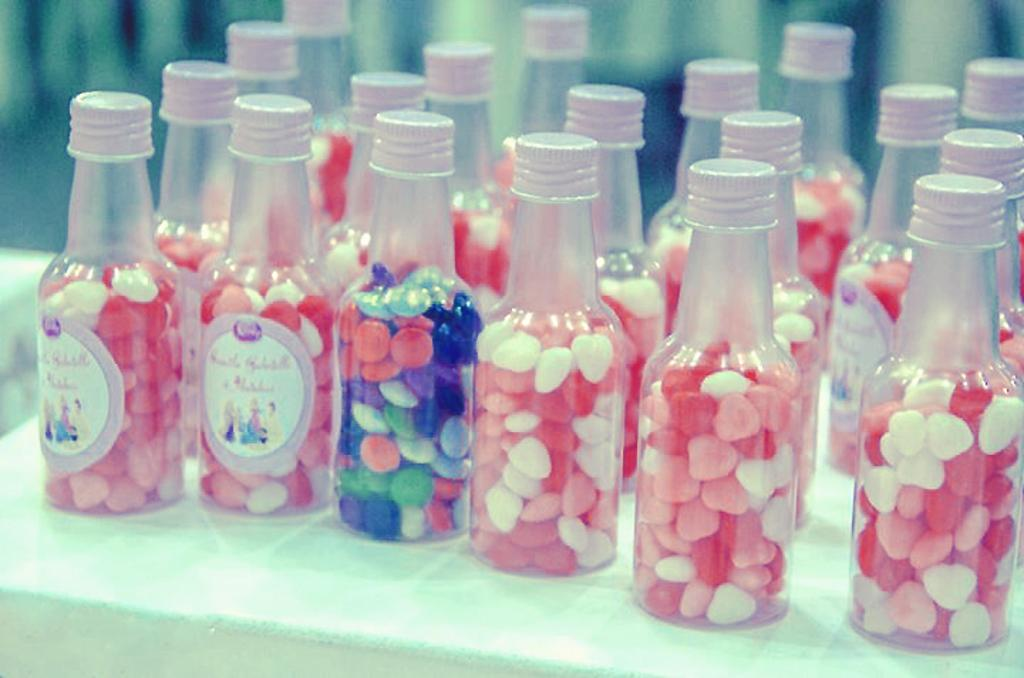What type of furniture is present in the image? There is a table in the image. What is placed on the table? There are many bottles on the table. What can be found inside the bottles? The bottles contain colorful items. What unit of measurement is used to determine the frame of the expert in the image? There is no unit of measurement, frame, or expert present in the image. 